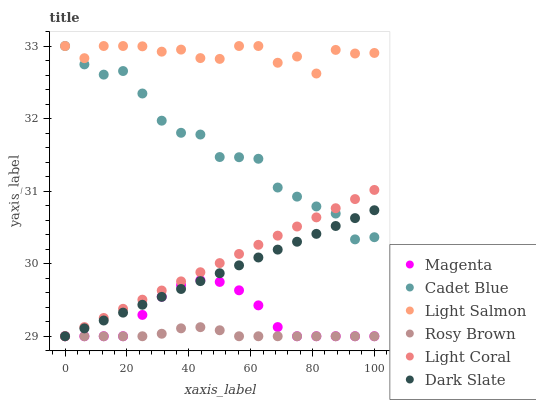Does Rosy Brown have the minimum area under the curve?
Answer yes or no. Yes. Does Light Salmon have the maximum area under the curve?
Answer yes or no. Yes. Does Cadet Blue have the minimum area under the curve?
Answer yes or no. No. Does Cadet Blue have the maximum area under the curve?
Answer yes or no. No. Is Light Coral the smoothest?
Answer yes or no. Yes. Is Light Salmon the roughest?
Answer yes or no. Yes. Is Cadet Blue the smoothest?
Answer yes or no. No. Is Cadet Blue the roughest?
Answer yes or no. No. Does Rosy Brown have the lowest value?
Answer yes or no. Yes. Does Cadet Blue have the lowest value?
Answer yes or no. No. Does Cadet Blue have the highest value?
Answer yes or no. Yes. Does Rosy Brown have the highest value?
Answer yes or no. No. Is Magenta less than Cadet Blue?
Answer yes or no. Yes. Is Light Salmon greater than Magenta?
Answer yes or no. Yes. Does Dark Slate intersect Cadet Blue?
Answer yes or no. Yes. Is Dark Slate less than Cadet Blue?
Answer yes or no. No. Is Dark Slate greater than Cadet Blue?
Answer yes or no. No. Does Magenta intersect Cadet Blue?
Answer yes or no. No. 